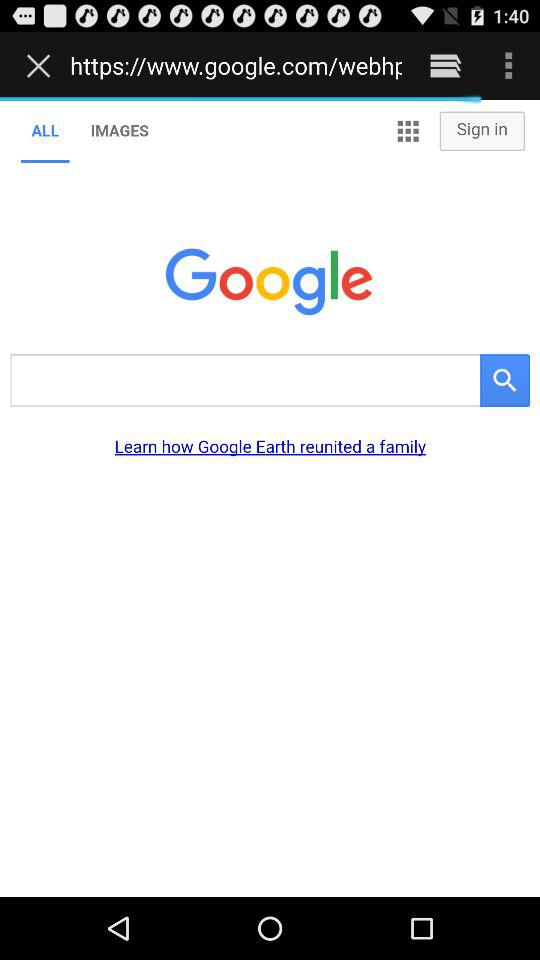Which option has been selected? The selected option is "ALL". 